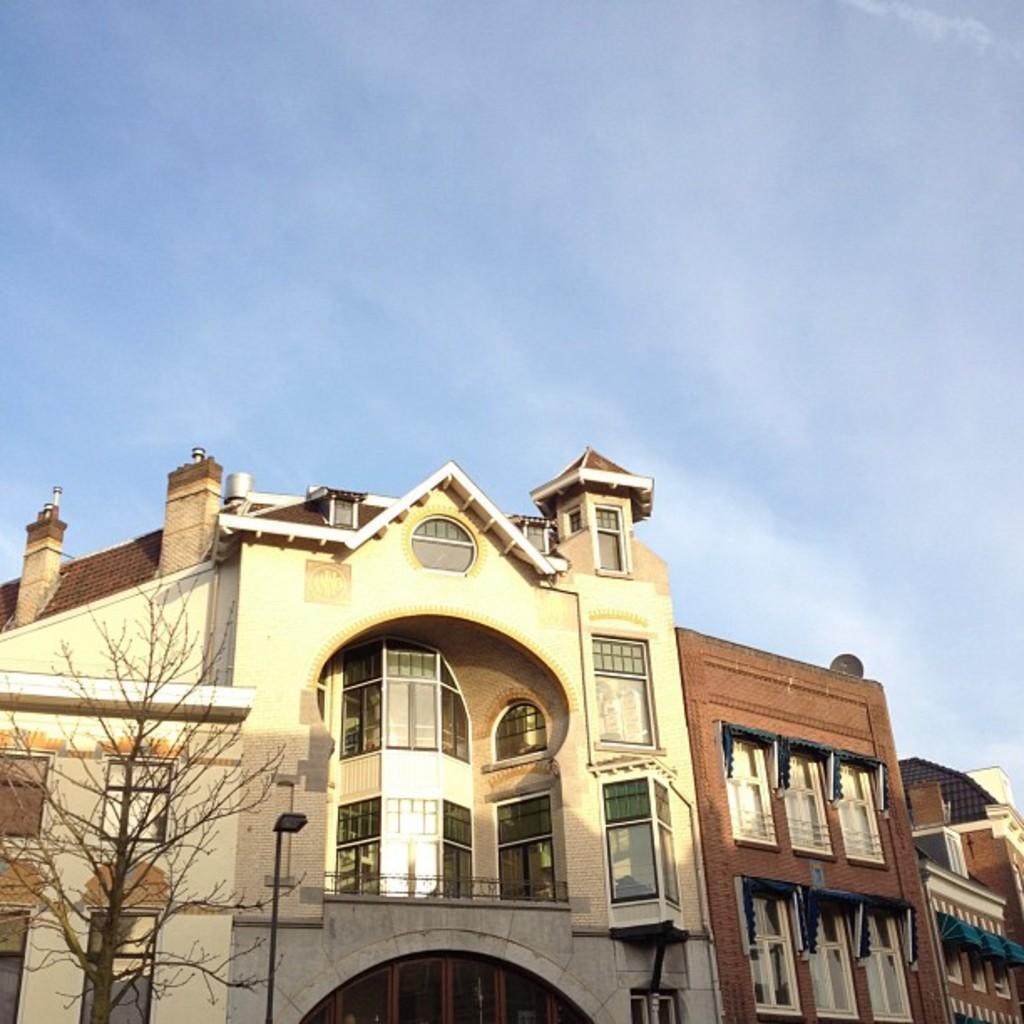How would you summarize this image in a sentence or two? This image is taken outdoors. At the top of the image there is the sky with clouds. In the middle of the image there are few buildings with walls, windows, doors, balconies and roofs. On the left side of the image there is a tree with stems and branches. 